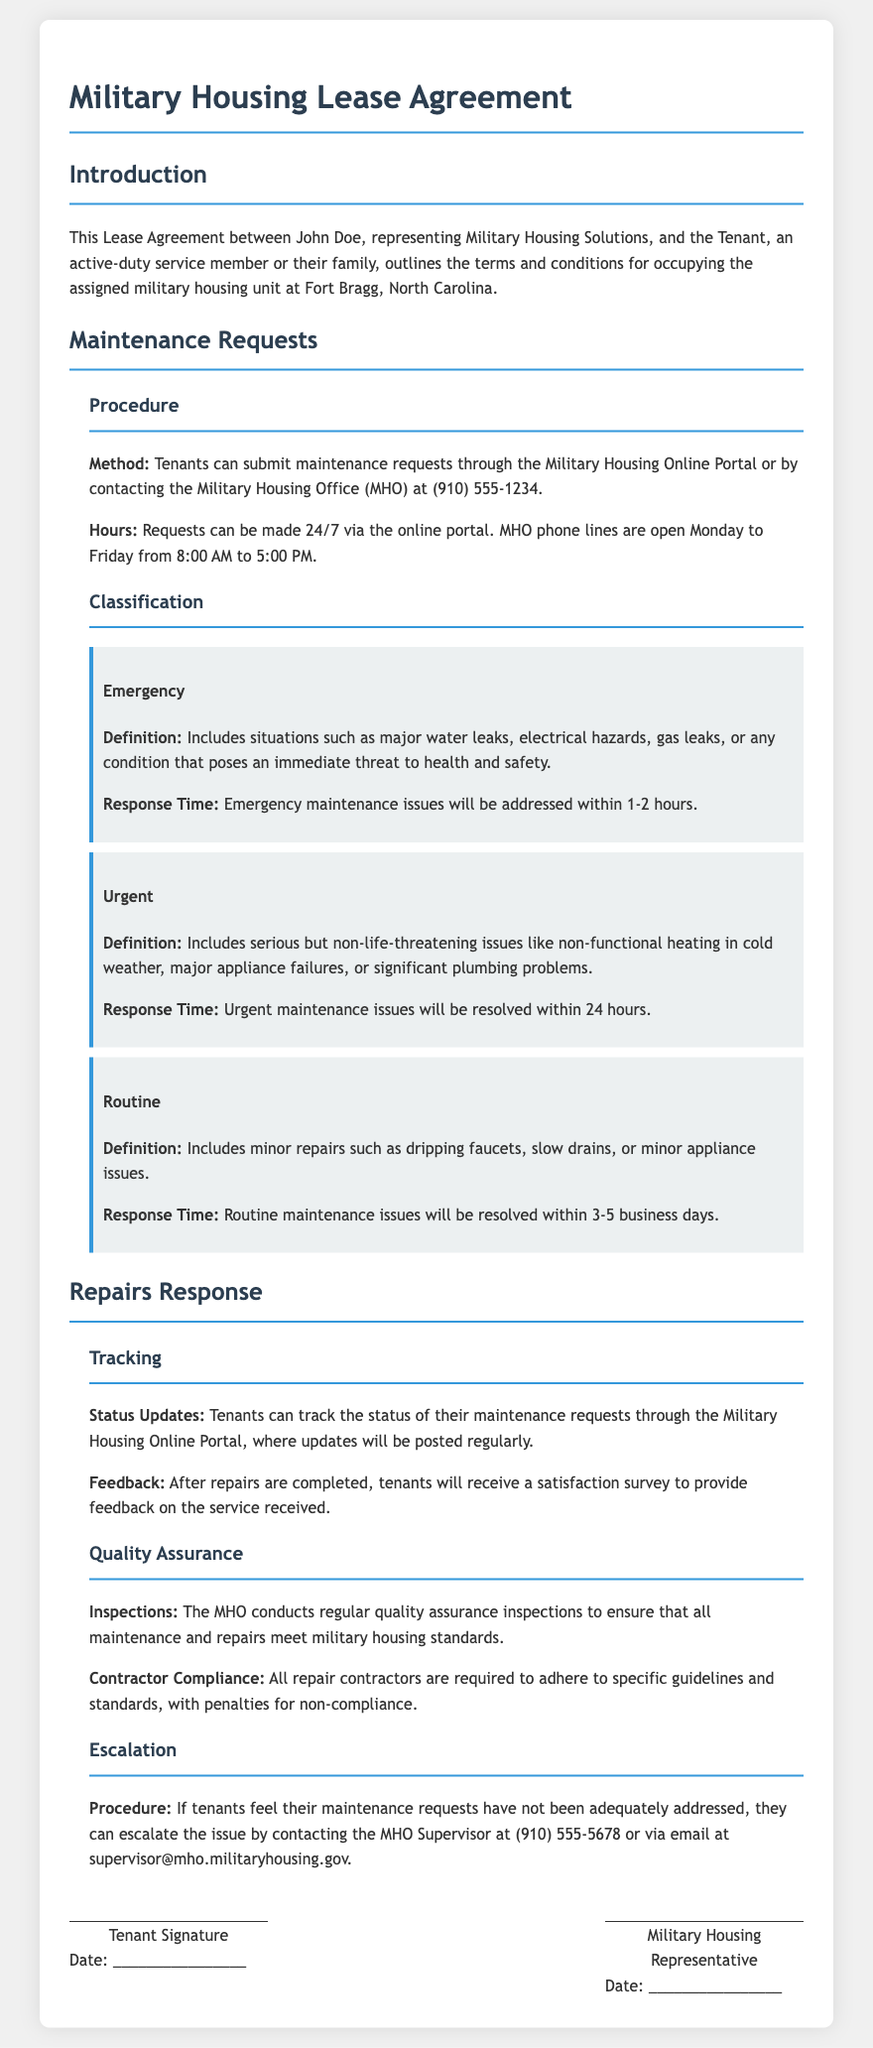What method can tenants use to submit maintenance requests? The method for submitting maintenance requests is either through the Military Housing Online Portal or by contacting the Military Housing Office.
Answer: Military Housing Online Portal or contacting MHO What is the phone number for the Military Housing Office? The document states that the contact number for the Military Housing Office is provided in the maintenance request procedure.
Answer: (910) 555-1234 What is the response time for emergency maintenance issues? The response time for emergency maintenance issues is specified in the document under the emergency classification.
Answer: 1-2 hours What type of issues are classified as urgent maintenance? The document lists serious but non-life-threatening issues as urgent, which includes non-functional heating in cold weather.
Answer: Non-functional heating in cold weather How can tenants track their maintenance requests? The tracking of maintenance requests is mentioned in the repairs response section of the document, indicating where tenants can find updates.
Answer: Military Housing Online Portal What should tenants do if their maintenance request is not adequately addressed? The document outlines an escalation procedure for tenants who feel their maintenance requests have not been handled satisfactorily.
Answer: Contact the MHO Supervisor What is the maximum response time for routine maintenance issues? The maximum response time for routine maintenance issues is stated in the routine classification of the maintenance section.
Answer: 3-5 business days What happens after repairs are completed? The document mentions that tenants will receive a satisfaction survey after their repairs are completed.
Answer: Satisfaction survey What are contractors required to comply with according to the quality assurance section? Contractors must adhere to specific guidelines and standards as indicated in the quality assurance section.
Answer: Specific guidelines and standards 